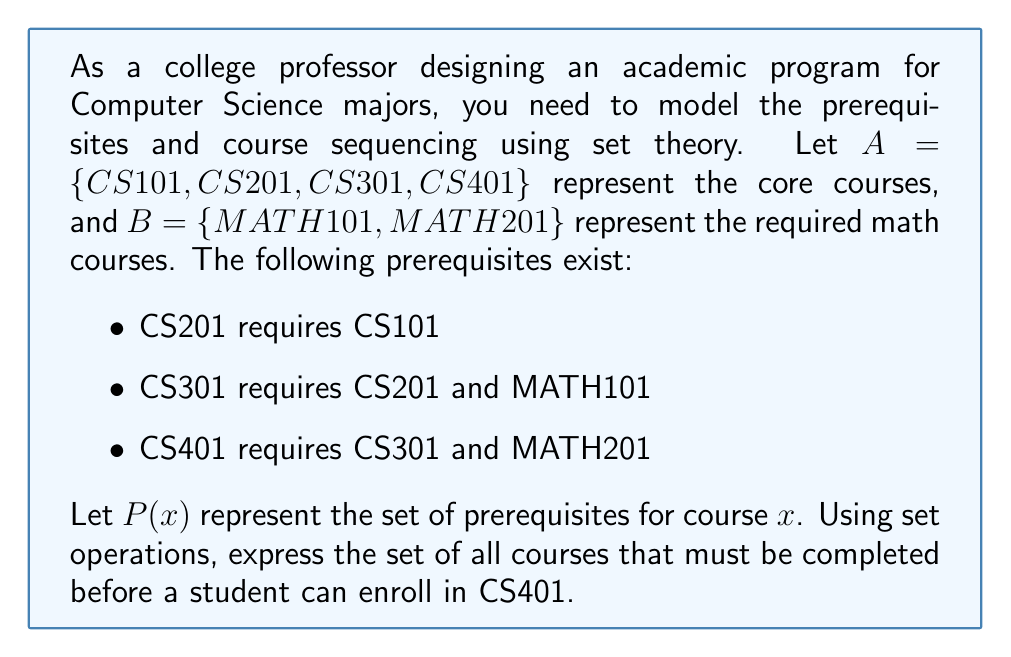Teach me how to tackle this problem. To solve this problem, we need to work backwards from CS401 and use set operations to combine all the prerequisites:

1) First, let's define the prerequisite sets for each course:
   $P(CS201) = \{CS101\}$
   $P(CS301) = \{CS201, MATH101\}$
   $P(CS401) = \{CS301, MATH201\}$

2) To find all courses that must be completed before CS401, we need to include:
   - The direct prerequisites of CS401
   - The prerequisites of CS301 (since CS301 is a prerequisite for CS401)
   - The prerequisites of CS201 (since CS201 is a prerequisite for CS301)

3) We can express this using set union operations:
   $P(CS401) \cup P(CS301) \cup P(CS201)$

4) Expanding this:
   $\{CS301, MATH201\} \cup \{CS201, MATH101\} \cup \{CS101\}$

5) Combining all these sets:
   $\{CS101, CS201, CS301, MATH101, MATH201\}$

This set represents all courses that must be completed before a student can enroll in CS401.
Answer: $\{CS101, CS201, CS301, MATH101, MATH201\}$ 